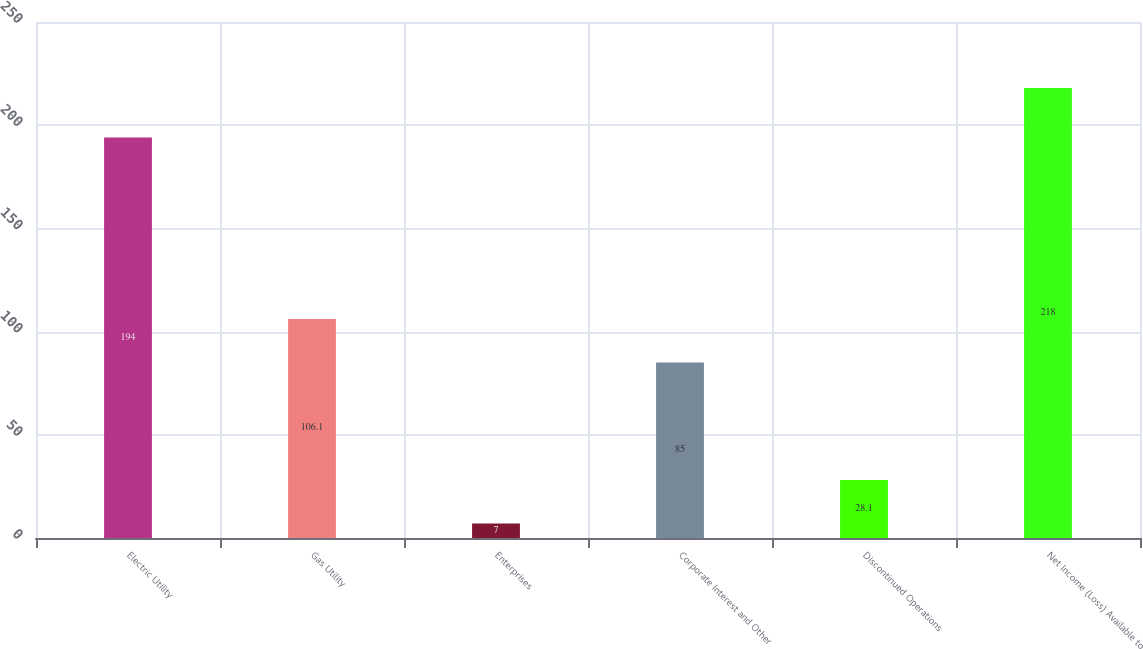Convert chart to OTSL. <chart><loc_0><loc_0><loc_500><loc_500><bar_chart><fcel>Electric Utility<fcel>Gas Utility<fcel>Enterprises<fcel>Corporate Interest and Other<fcel>Discontinued Operations<fcel>Net Income (Loss) Available to<nl><fcel>194<fcel>106.1<fcel>7<fcel>85<fcel>28.1<fcel>218<nl></chart> 